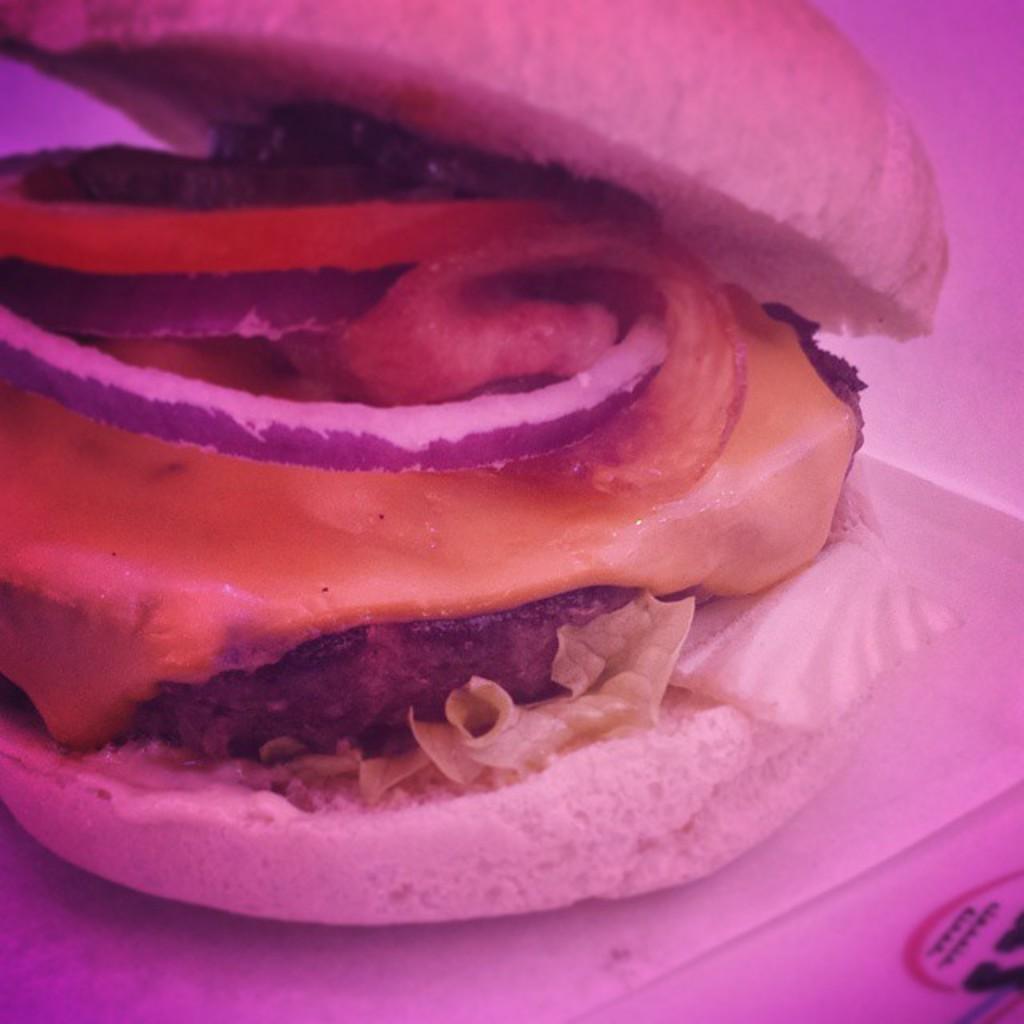Could you give a brief overview of what you see in this image? In this image we can see a hamburger on a surface, with cheese, onion, and tomato slices in it. 